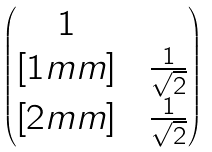<formula> <loc_0><loc_0><loc_500><loc_500>\begin{pmatrix} 1 & & \\ [ 1 m m ] & & \frac { 1 } { \sqrt { 2 } } \\ [ 2 m m ] & & \frac { 1 } { \sqrt { 2 } } \end{pmatrix}</formula> 